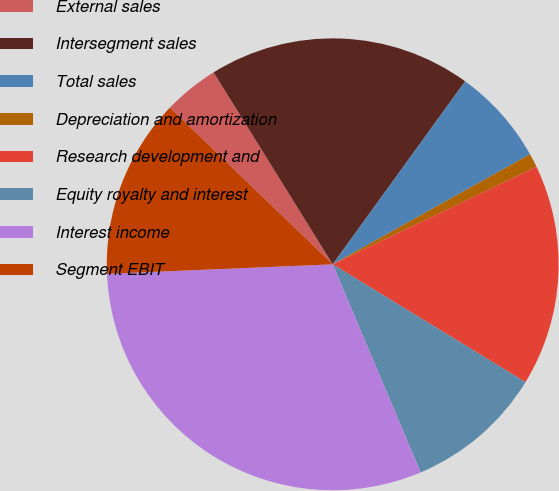Convert chart to OTSL. <chart><loc_0><loc_0><loc_500><loc_500><pie_chart><fcel>External sales<fcel>Intersegment sales<fcel>Total sales<fcel>Depreciation and amortization<fcel>Research development and<fcel>Equity royalty and interest<fcel>Interest income<fcel>Segment EBIT<nl><fcel>3.96%<fcel>18.81%<fcel>6.93%<fcel>0.99%<fcel>15.84%<fcel>9.9%<fcel>30.69%<fcel>12.87%<nl></chart> 